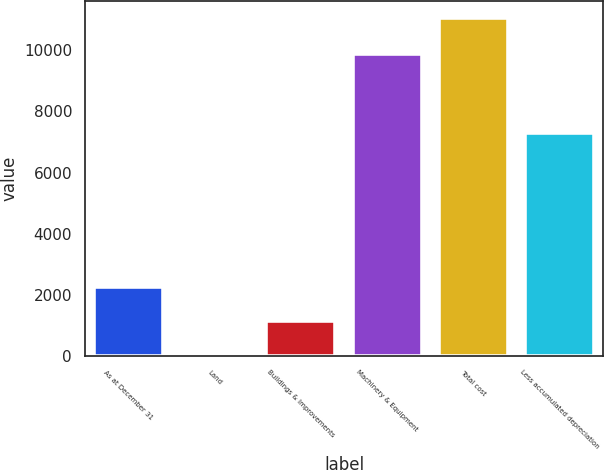<chart> <loc_0><loc_0><loc_500><loc_500><bar_chart><fcel>As at December 31<fcel>Land<fcel>Buildings & Improvements<fcel>Machinery & Equipment<fcel>Total cost<fcel>Less accumulated depreciation<nl><fcel>2260.2<fcel>58<fcel>1159.1<fcel>9876<fcel>11069<fcel>7307<nl></chart> 